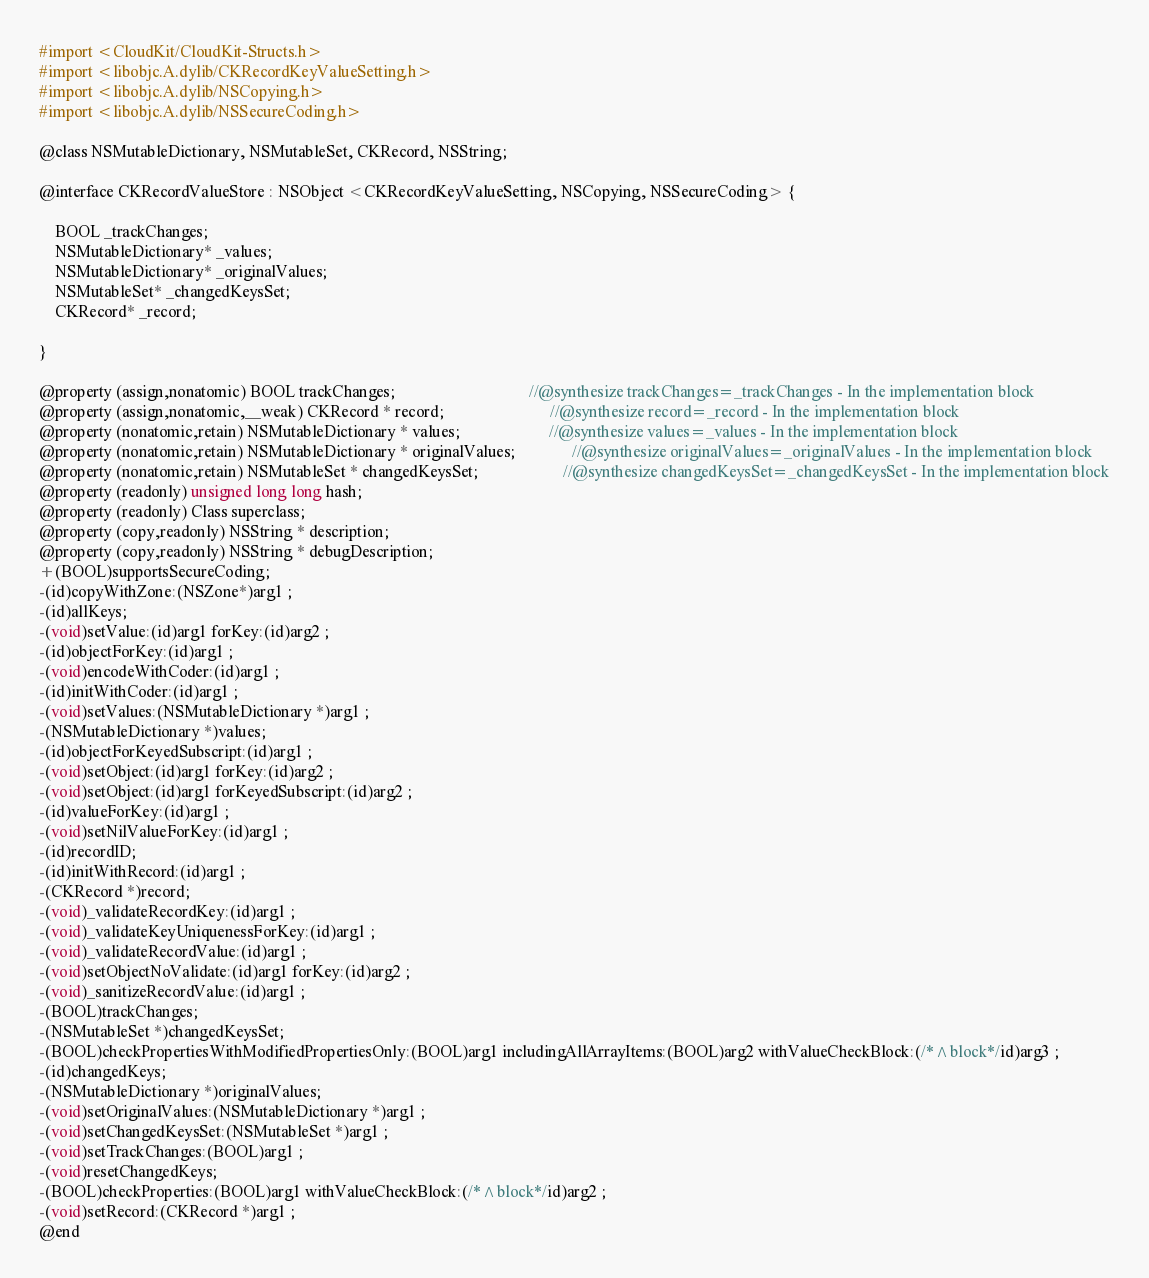Convert code to text. <code><loc_0><loc_0><loc_500><loc_500><_C_>
#import <CloudKit/CloudKit-Structs.h>
#import <libobjc.A.dylib/CKRecordKeyValueSetting.h>
#import <libobjc.A.dylib/NSCopying.h>
#import <libobjc.A.dylib/NSSecureCoding.h>

@class NSMutableDictionary, NSMutableSet, CKRecord, NSString;

@interface CKRecordValueStore : NSObject <CKRecordKeyValueSetting, NSCopying, NSSecureCoding> {

	BOOL _trackChanges;
	NSMutableDictionary* _values;
	NSMutableDictionary* _originalValues;
	NSMutableSet* _changedKeysSet;
	CKRecord* _record;

}

@property (assign,nonatomic) BOOL trackChanges;                                 //@synthesize trackChanges=_trackChanges - In the implementation block
@property (assign,nonatomic,__weak) CKRecord * record;                          //@synthesize record=_record - In the implementation block
@property (nonatomic,retain) NSMutableDictionary * values;                      //@synthesize values=_values - In the implementation block
@property (nonatomic,retain) NSMutableDictionary * originalValues;              //@synthesize originalValues=_originalValues - In the implementation block
@property (nonatomic,retain) NSMutableSet * changedKeysSet;                     //@synthesize changedKeysSet=_changedKeysSet - In the implementation block
@property (readonly) unsigned long long hash; 
@property (readonly) Class superclass; 
@property (copy,readonly) NSString * description; 
@property (copy,readonly) NSString * debugDescription; 
+(BOOL)supportsSecureCoding;
-(id)copyWithZone:(NSZone*)arg1 ;
-(id)allKeys;
-(void)setValue:(id)arg1 forKey:(id)arg2 ;
-(id)objectForKey:(id)arg1 ;
-(void)encodeWithCoder:(id)arg1 ;
-(id)initWithCoder:(id)arg1 ;
-(void)setValues:(NSMutableDictionary *)arg1 ;
-(NSMutableDictionary *)values;
-(id)objectForKeyedSubscript:(id)arg1 ;
-(void)setObject:(id)arg1 forKey:(id)arg2 ;
-(void)setObject:(id)arg1 forKeyedSubscript:(id)arg2 ;
-(id)valueForKey:(id)arg1 ;
-(void)setNilValueForKey:(id)arg1 ;
-(id)recordID;
-(id)initWithRecord:(id)arg1 ;
-(CKRecord *)record;
-(void)_validateRecordKey:(id)arg1 ;
-(void)_validateKeyUniquenessForKey:(id)arg1 ;
-(void)_validateRecordValue:(id)arg1 ;
-(void)setObjectNoValidate:(id)arg1 forKey:(id)arg2 ;
-(void)_sanitizeRecordValue:(id)arg1 ;
-(BOOL)trackChanges;
-(NSMutableSet *)changedKeysSet;
-(BOOL)checkPropertiesWithModifiedPropertiesOnly:(BOOL)arg1 includingAllArrayItems:(BOOL)arg2 withValueCheckBlock:(/*^block*/id)arg3 ;
-(id)changedKeys;
-(NSMutableDictionary *)originalValues;
-(void)setOriginalValues:(NSMutableDictionary *)arg1 ;
-(void)setChangedKeysSet:(NSMutableSet *)arg1 ;
-(void)setTrackChanges:(BOOL)arg1 ;
-(void)resetChangedKeys;
-(BOOL)checkProperties:(BOOL)arg1 withValueCheckBlock:(/*^block*/id)arg2 ;
-(void)setRecord:(CKRecord *)arg1 ;
@end

</code> 